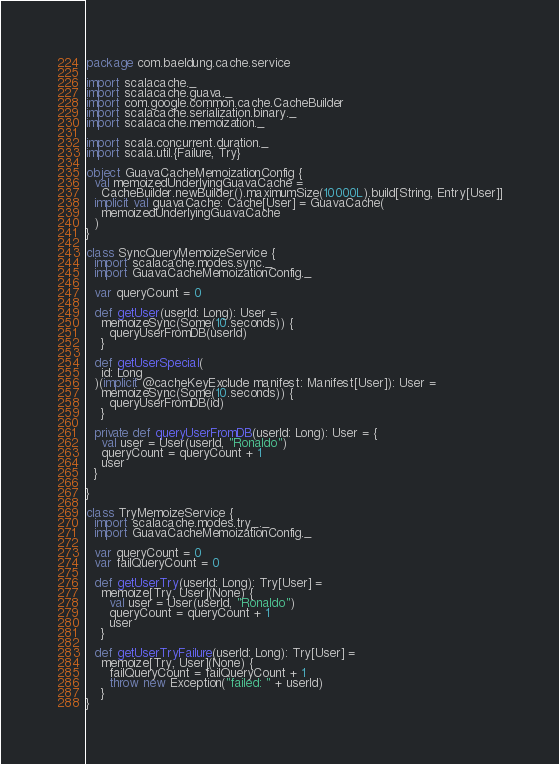Convert code to text. <code><loc_0><loc_0><loc_500><loc_500><_Scala_>package com.baeldung.cache.service

import scalacache._
import scalacache.guava._
import com.google.common.cache.CacheBuilder
import scalacache.serialization.binary._
import scalacache.memoization._

import scala.concurrent.duration._
import scala.util.{Failure, Try}

object GuavaCacheMemoizationConfig {
  val memoizedUnderlyingGuavaCache =
    CacheBuilder.newBuilder().maximumSize(10000L).build[String, Entry[User]]
  implicit val guavaCache: Cache[User] = GuavaCache(
    memoizedUnderlyingGuavaCache
  )
}

class SyncQueryMemoizeService {
  import scalacache.modes.sync._
  import GuavaCacheMemoizationConfig._

  var queryCount = 0

  def getUser(userId: Long): User =
    memoizeSync(Some(10.seconds)) {
      queryUserFromDB(userId)
    }

  def getUserSpecial(
    id: Long
  )(implicit @cacheKeyExclude manifest: Manifest[User]): User =
    memoizeSync(Some(10.seconds)) {
      queryUserFromDB(id)
    }

  private def queryUserFromDB(userId: Long): User = {
    val user = User(userId, "Ronaldo")
    queryCount = queryCount + 1
    user
  }

}

class TryMemoizeService {
  import scalacache.modes.try_._
  import GuavaCacheMemoizationConfig._

  var queryCount = 0
  var failQueryCount = 0

  def getUserTry(userId: Long): Try[User] =
    memoize[Try, User](None) {
      val user = User(userId, "Ronaldo")
      queryCount = queryCount + 1
      user
    }

  def getUserTryFailure(userId: Long): Try[User] =
    memoize[Try, User](None) {
      failQueryCount = failQueryCount + 1
      throw new Exception("failed: " + userId)
    }
}
</code> 